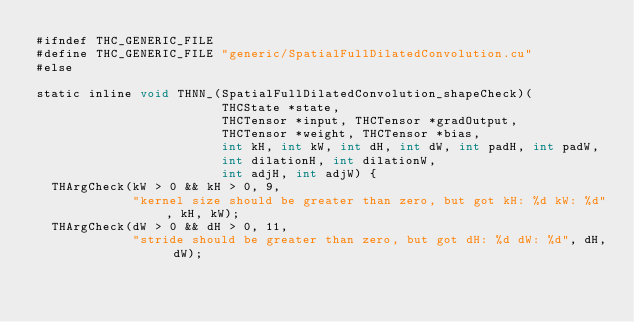<code> <loc_0><loc_0><loc_500><loc_500><_Cuda_>#ifndef THC_GENERIC_FILE
#define THC_GENERIC_FILE "generic/SpatialFullDilatedConvolution.cu"
#else

static inline void THNN_(SpatialFullDilatedConvolution_shapeCheck)(
                         THCState *state,
                         THCTensor *input, THCTensor *gradOutput,
                         THCTensor *weight, THCTensor *bias,
                         int kH, int kW, int dH, int dW, int padH, int padW,
                         int dilationH, int dilationW,
                         int adjH, int adjW) {
  THArgCheck(kW > 0 && kH > 0, 9,
             "kernel size should be greater than zero, but got kH: %d kW: %d", kH, kW);
  THArgCheck(dW > 0 && dH > 0, 11,
             "stride should be greater than zero, but got dH: %d dW: %d", dH, dW);</code> 